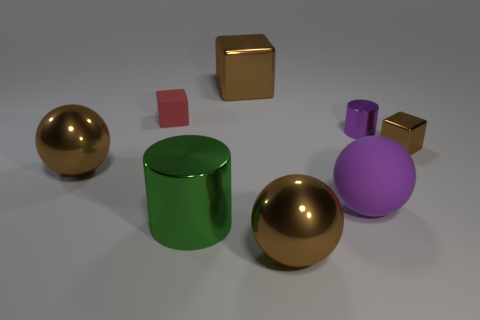What color is the large ball that is on the left side of the brown shiny sphere in front of the big thing that is left of the red matte cube?
Provide a short and direct response. Brown. What number of brown things are blocks or big matte cylinders?
Offer a very short reply. 2. What number of big brown things have the same shape as the tiny brown thing?
Your answer should be compact. 1. The brown object that is the same size as the red block is what shape?
Keep it short and to the point. Cube. Are there any small purple cylinders in front of the green shiny cylinder?
Keep it short and to the point. No. There is a large shiny ball to the left of the tiny red rubber thing; is there a large brown object in front of it?
Keep it short and to the point. Yes. Is the number of green cylinders behind the red matte object less than the number of large brown shiny blocks that are on the right side of the tiny brown thing?
Give a very brief answer. No. Is there anything else that has the same size as the red matte thing?
Your answer should be very brief. Yes. What shape is the green thing?
Provide a succinct answer. Cylinder. There is a brown ball left of the big green thing; what is its material?
Offer a very short reply. Metal. 